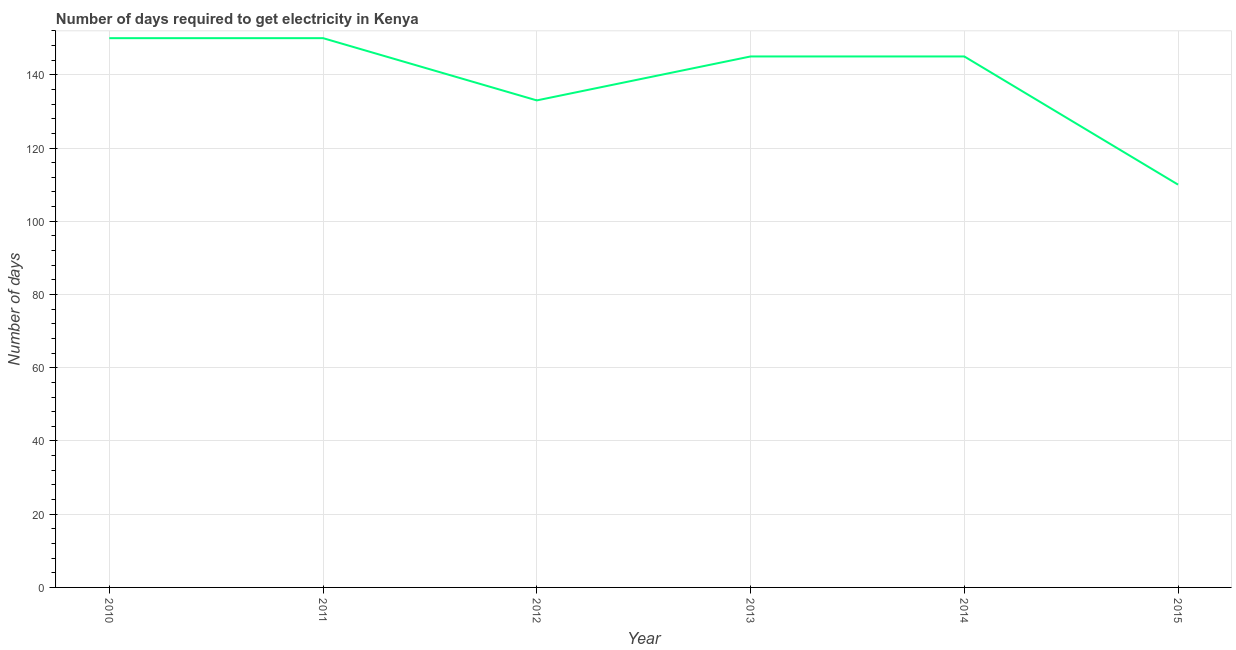What is the time to get electricity in 2013?
Provide a succinct answer. 145. Across all years, what is the maximum time to get electricity?
Provide a succinct answer. 150. Across all years, what is the minimum time to get electricity?
Offer a very short reply. 110. In which year was the time to get electricity minimum?
Give a very brief answer. 2015. What is the sum of the time to get electricity?
Offer a terse response. 833. What is the difference between the time to get electricity in 2011 and 2015?
Keep it short and to the point. 40. What is the average time to get electricity per year?
Provide a succinct answer. 138.83. What is the median time to get electricity?
Offer a very short reply. 145. In how many years, is the time to get electricity greater than 112 ?
Provide a succinct answer. 5. What is the ratio of the time to get electricity in 2010 to that in 2014?
Your answer should be very brief. 1.03. Is the time to get electricity in 2011 less than that in 2013?
Offer a terse response. No. What is the difference between the highest and the lowest time to get electricity?
Make the answer very short. 40. In how many years, is the time to get electricity greater than the average time to get electricity taken over all years?
Make the answer very short. 4. How many lines are there?
Offer a very short reply. 1. What is the difference between two consecutive major ticks on the Y-axis?
Your answer should be very brief. 20. Are the values on the major ticks of Y-axis written in scientific E-notation?
Keep it short and to the point. No. Does the graph contain any zero values?
Your answer should be compact. No. Does the graph contain grids?
Keep it short and to the point. Yes. What is the title of the graph?
Ensure brevity in your answer.  Number of days required to get electricity in Kenya. What is the label or title of the X-axis?
Provide a short and direct response. Year. What is the label or title of the Y-axis?
Give a very brief answer. Number of days. What is the Number of days in 2010?
Your answer should be very brief. 150. What is the Number of days in 2011?
Offer a very short reply. 150. What is the Number of days in 2012?
Offer a terse response. 133. What is the Number of days of 2013?
Provide a succinct answer. 145. What is the Number of days of 2014?
Your answer should be very brief. 145. What is the Number of days of 2015?
Your answer should be very brief. 110. What is the difference between the Number of days in 2010 and 2014?
Keep it short and to the point. 5. What is the difference between the Number of days in 2010 and 2015?
Provide a succinct answer. 40. What is the difference between the Number of days in 2012 and 2015?
Give a very brief answer. 23. What is the difference between the Number of days in 2013 and 2014?
Your response must be concise. 0. What is the difference between the Number of days in 2013 and 2015?
Offer a very short reply. 35. What is the difference between the Number of days in 2014 and 2015?
Offer a terse response. 35. What is the ratio of the Number of days in 2010 to that in 2012?
Offer a terse response. 1.13. What is the ratio of the Number of days in 2010 to that in 2013?
Your answer should be very brief. 1.03. What is the ratio of the Number of days in 2010 to that in 2014?
Your answer should be very brief. 1.03. What is the ratio of the Number of days in 2010 to that in 2015?
Ensure brevity in your answer.  1.36. What is the ratio of the Number of days in 2011 to that in 2012?
Your answer should be compact. 1.13. What is the ratio of the Number of days in 2011 to that in 2013?
Offer a terse response. 1.03. What is the ratio of the Number of days in 2011 to that in 2014?
Your response must be concise. 1.03. What is the ratio of the Number of days in 2011 to that in 2015?
Keep it short and to the point. 1.36. What is the ratio of the Number of days in 2012 to that in 2013?
Offer a very short reply. 0.92. What is the ratio of the Number of days in 2012 to that in 2014?
Offer a terse response. 0.92. What is the ratio of the Number of days in 2012 to that in 2015?
Make the answer very short. 1.21. What is the ratio of the Number of days in 2013 to that in 2015?
Provide a short and direct response. 1.32. What is the ratio of the Number of days in 2014 to that in 2015?
Make the answer very short. 1.32. 